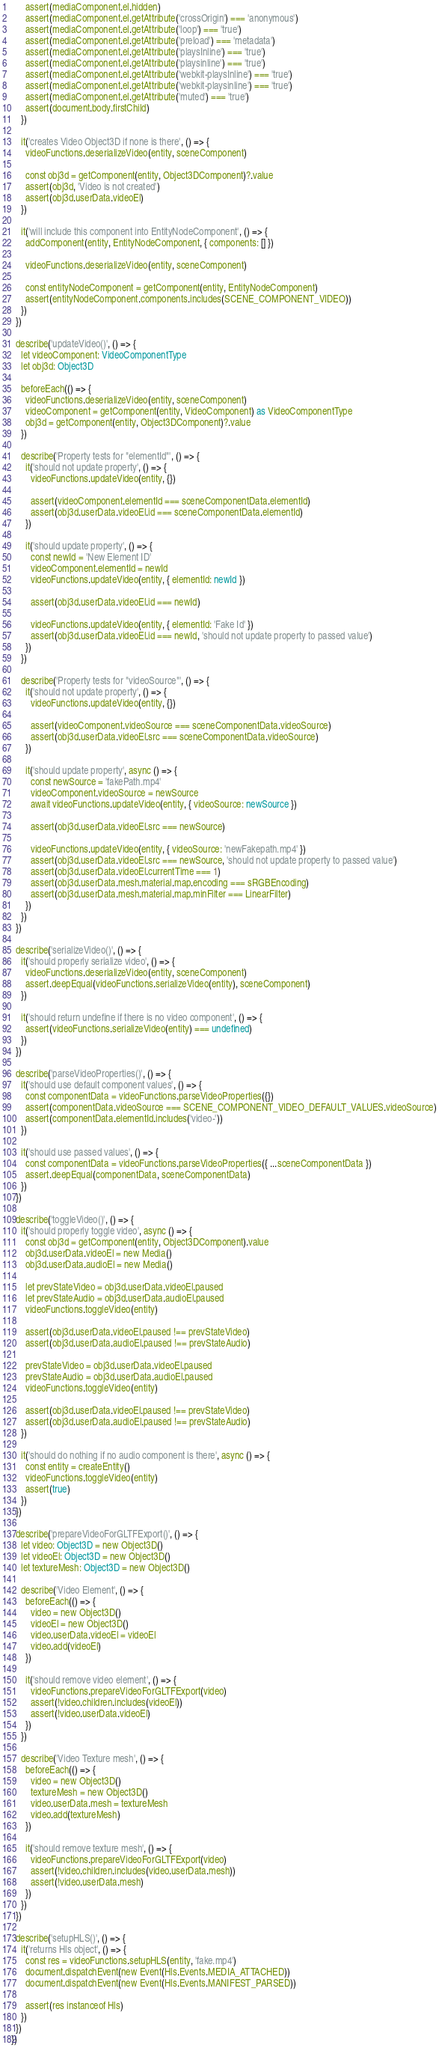<code> <loc_0><loc_0><loc_500><loc_500><_TypeScript_>      assert(mediaComponent.el.hidden)
      assert(mediaComponent.el.getAttribute('crossOrigin') === 'anonymous')
      assert(mediaComponent.el.getAttribute('loop') === 'true')
      assert(mediaComponent.el.getAttribute('preload') === 'metadata')
      assert(mediaComponent.el.getAttribute('playsInline') === 'true')
      assert(mediaComponent.el.getAttribute('playsinline') === 'true')
      assert(mediaComponent.el.getAttribute('webkit-playsInline') === 'true')
      assert(mediaComponent.el.getAttribute('webkit-playsinline') === 'true')
      assert(mediaComponent.el.getAttribute('muted') === 'true')
      assert(document.body.firstChild)
    })

    it('creates Video Object3D if none is there', () => {
      videoFunctions.deserializeVideo(entity, sceneComponent)

      const obj3d = getComponent(entity, Object3DComponent)?.value
      assert(obj3d, 'Video is not created')
      assert(obj3d.userData.videoEl)
    })

    it('will include this component into EntityNodeComponent', () => {
      addComponent(entity, EntityNodeComponent, { components: [] })

      videoFunctions.deserializeVideo(entity, sceneComponent)

      const entityNodeComponent = getComponent(entity, EntityNodeComponent)
      assert(entityNodeComponent.components.includes(SCENE_COMPONENT_VIDEO))
    })
  })

  describe('updateVideo()', () => {
    let videoComponent: VideoComponentType
    let obj3d: Object3D

    beforeEach(() => {
      videoFunctions.deserializeVideo(entity, sceneComponent)
      videoComponent = getComponent(entity, VideoComponent) as VideoComponentType
      obj3d = getComponent(entity, Object3DComponent)?.value
    })

    describe('Property tests for "elementId"', () => {
      it('should not update property', () => {
        videoFunctions.updateVideo(entity, {})

        assert(videoComponent.elementId === sceneComponentData.elementId)
        assert(obj3d.userData.videoEl.id === sceneComponentData.elementId)
      })

      it('should update property', () => {
        const newId = 'New Element ID'
        videoComponent.elementId = newId
        videoFunctions.updateVideo(entity, { elementId: newId })

        assert(obj3d.userData.videoEl.id === newId)

        videoFunctions.updateVideo(entity, { elementId: 'Fake Id' })
        assert(obj3d.userData.videoEl.id === newId, 'should not update property to passed value')
      })
    })

    describe('Property tests for "videoSource"', () => {
      it('should not update property', () => {
        videoFunctions.updateVideo(entity, {})

        assert(videoComponent.videoSource === sceneComponentData.videoSource)
        assert(obj3d.userData.videoEl.src === sceneComponentData.videoSource)
      })

      it('should update property', async () => {
        const newSource = 'fakePath.mp4'
        videoComponent.videoSource = newSource
        await videoFunctions.updateVideo(entity, { videoSource: newSource })

        assert(obj3d.userData.videoEl.src === newSource)

        videoFunctions.updateVideo(entity, { videoSource: 'newFakepath.mp4' })
        assert(obj3d.userData.videoEl.src === newSource, 'should not update property to passed value')
        assert(obj3d.userData.videoEl.currentTime === 1)
        assert(obj3d.userData.mesh.material.map.encoding === sRGBEncoding)
        assert(obj3d.userData.mesh.material.map.minFilter === LinearFilter)
      })
    })
  })

  describe('serializeVideo()', () => {
    it('should properly serialize video', () => {
      videoFunctions.deserializeVideo(entity, sceneComponent)
      assert.deepEqual(videoFunctions.serializeVideo(entity), sceneComponent)
    })

    it('should return undefine if there is no video component', () => {
      assert(videoFunctions.serializeVideo(entity) === undefined)
    })
  })

  describe('parseVideoProperties()', () => {
    it('should use default component values', () => {
      const componentData = videoFunctions.parseVideoProperties({})
      assert(componentData.videoSource === SCENE_COMPONENT_VIDEO_DEFAULT_VALUES.videoSource)
      assert(componentData.elementId.includes('video-'))
    })

    it('should use passed values', () => {
      const componentData = videoFunctions.parseVideoProperties({ ...sceneComponentData })
      assert.deepEqual(componentData, sceneComponentData)
    })
  })

  describe('toggleVideo()', () => {
    it('should properly toggle video', async () => {
      const obj3d = getComponent(entity, Object3DComponent).value
      obj3d.userData.videoEl = new Media()
      obj3d.userData.audioEl = new Media()

      let prevStateVideo = obj3d.userData.videoEl.paused
      let prevStateAudio = obj3d.userData.audioEl.paused
      videoFunctions.toggleVideo(entity)

      assert(obj3d.userData.videoEl.paused !== prevStateVideo)
      assert(obj3d.userData.audioEl.paused !== prevStateAudio)

      prevStateVideo = obj3d.userData.videoEl.paused
      prevStateAudio = obj3d.userData.audioEl.paused
      videoFunctions.toggleVideo(entity)

      assert(obj3d.userData.videoEl.paused !== prevStateVideo)
      assert(obj3d.userData.audioEl.paused !== prevStateAudio)
    })

    it('should do nothing if no audio component is there', async () => {
      const entity = createEntity()
      videoFunctions.toggleVideo(entity)
      assert(true)
    })
  })

  describe('prepareVideoForGLTFExport()', () => {
    let video: Object3D = new Object3D()
    let videoEl: Object3D = new Object3D()
    let textureMesh: Object3D = new Object3D()

    describe('Video Element', () => {
      beforeEach(() => {
        video = new Object3D()
        videoEl = new Object3D()
        video.userData.videoEl = videoEl
        video.add(videoEl)
      })

      it('should remove video element', () => {
        videoFunctions.prepareVideoForGLTFExport(video)
        assert(!video.children.includes(videoEl))
        assert(!video.userData.videoEl)
      })
    })

    describe('Video Texture mesh', () => {
      beforeEach(() => {
        video = new Object3D()
        textureMesh = new Object3D()
        video.userData.mesh = textureMesh
        video.add(textureMesh)
      })

      it('should remove texture mesh', () => {
        videoFunctions.prepareVideoForGLTFExport(video)
        assert(!video.children.includes(video.userData.mesh))
        assert(!video.userData.mesh)
      })
    })
  })

  describe('setupHLS()', () => {
    it('returns Hls object', () => {
      const res = videoFunctions.setupHLS(entity, 'fake.mp4')
      document.dispatchEvent(new Event(Hls.Events.MEDIA_ATTACHED))
      document.dispatchEvent(new Event(Hls.Events.MANIFEST_PARSED))

      assert(res instanceof Hls)
    })
  })
})
</code> 